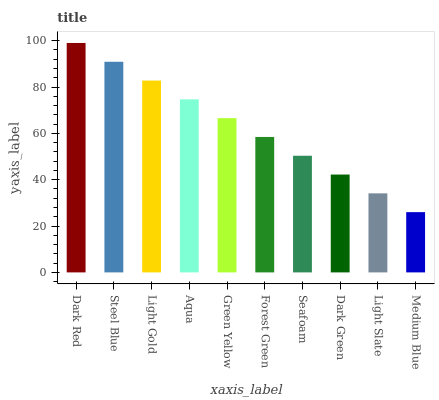Is Medium Blue the minimum?
Answer yes or no. Yes. Is Dark Red the maximum?
Answer yes or no. Yes. Is Steel Blue the minimum?
Answer yes or no. No. Is Steel Blue the maximum?
Answer yes or no. No. Is Dark Red greater than Steel Blue?
Answer yes or no. Yes. Is Steel Blue less than Dark Red?
Answer yes or no. Yes. Is Steel Blue greater than Dark Red?
Answer yes or no. No. Is Dark Red less than Steel Blue?
Answer yes or no. No. Is Green Yellow the high median?
Answer yes or no. Yes. Is Forest Green the low median?
Answer yes or no. Yes. Is Light Slate the high median?
Answer yes or no. No. Is Dark Red the low median?
Answer yes or no. No. 